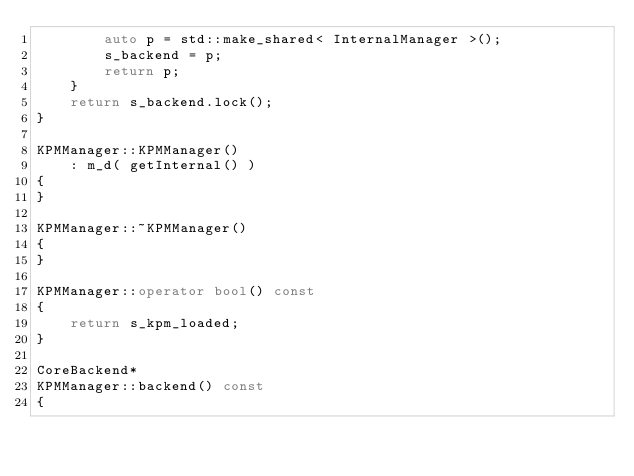Convert code to text. <code><loc_0><loc_0><loc_500><loc_500><_C++_>        auto p = std::make_shared< InternalManager >();
        s_backend = p;
        return p;
    }
    return s_backend.lock();
}

KPMManager::KPMManager()
    : m_d( getInternal() )
{
}

KPMManager::~KPMManager()
{
}

KPMManager::operator bool() const
{
    return s_kpm_loaded;
}

CoreBackend*
KPMManager::backend() const
{</code> 